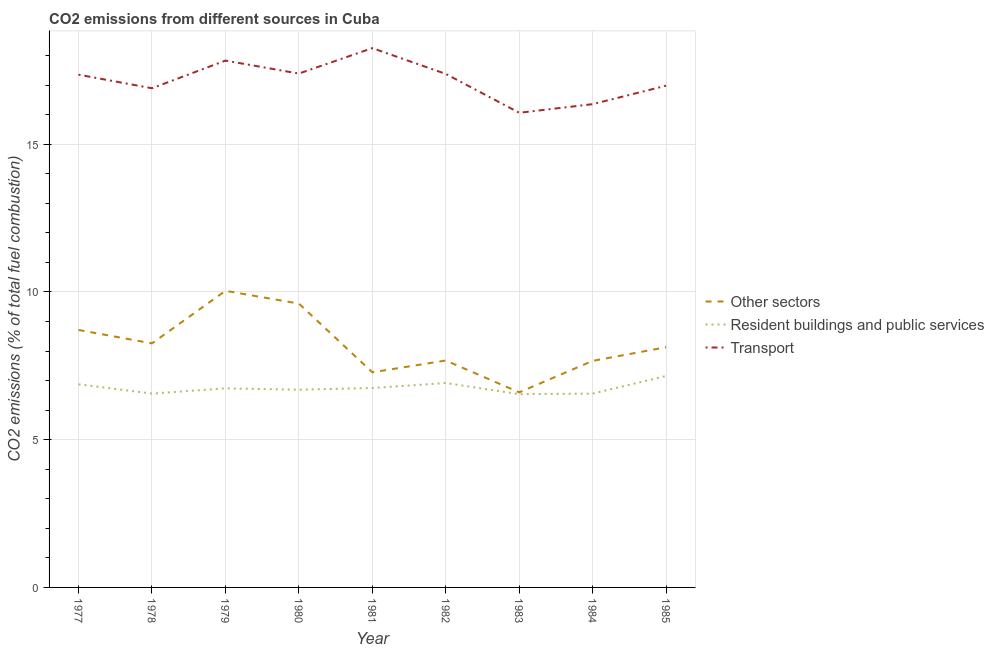How many different coloured lines are there?
Offer a terse response. 3. What is the percentage of co2 emissions from transport in 1982?
Give a very brief answer. 17.38. Across all years, what is the maximum percentage of co2 emissions from transport?
Keep it short and to the point. 18.25. Across all years, what is the minimum percentage of co2 emissions from transport?
Offer a terse response. 16.06. In which year was the percentage of co2 emissions from resident buildings and public services minimum?
Give a very brief answer. 1983. What is the total percentage of co2 emissions from resident buildings and public services in the graph?
Provide a succinct answer. 60.79. What is the difference between the percentage of co2 emissions from transport in 1980 and that in 1981?
Your answer should be compact. -0.86. What is the difference between the percentage of co2 emissions from transport in 1983 and the percentage of co2 emissions from other sectors in 1979?
Provide a short and direct response. 6.03. What is the average percentage of co2 emissions from transport per year?
Keep it short and to the point. 17.17. In the year 1982, what is the difference between the percentage of co2 emissions from transport and percentage of co2 emissions from other sectors?
Provide a succinct answer. 9.7. What is the ratio of the percentage of co2 emissions from resident buildings and public services in 1981 to that in 1985?
Offer a very short reply. 0.94. Is the difference between the percentage of co2 emissions from other sectors in 1977 and 1980 greater than the difference between the percentage of co2 emissions from transport in 1977 and 1980?
Provide a short and direct response. No. What is the difference between the highest and the second highest percentage of co2 emissions from transport?
Your answer should be very brief. 0.42. What is the difference between the highest and the lowest percentage of co2 emissions from other sectors?
Your answer should be very brief. 3.44. Is the sum of the percentage of co2 emissions from resident buildings and public services in 1982 and 1984 greater than the maximum percentage of co2 emissions from other sectors across all years?
Make the answer very short. Yes. Does the percentage of co2 emissions from resident buildings and public services monotonically increase over the years?
Give a very brief answer. No. Is the percentage of co2 emissions from transport strictly greater than the percentage of co2 emissions from other sectors over the years?
Your response must be concise. Yes. Is the percentage of co2 emissions from other sectors strictly less than the percentage of co2 emissions from transport over the years?
Ensure brevity in your answer.  Yes. What is the title of the graph?
Give a very brief answer. CO2 emissions from different sources in Cuba. Does "Argument" appear as one of the legend labels in the graph?
Your answer should be very brief. No. What is the label or title of the Y-axis?
Keep it short and to the point. CO2 emissions (% of total fuel combustion). What is the CO2 emissions (% of total fuel combustion) in Other sectors in 1977?
Give a very brief answer. 8.71. What is the CO2 emissions (% of total fuel combustion) in Resident buildings and public services in 1977?
Give a very brief answer. 6.88. What is the CO2 emissions (% of total fuel combustion) in Transport in 1977?
Your answer should be very brief. 17.35. What is the CO2 emissions (% of total fuel combustion) of Other sectors in 1978?
Make the answer very short. 8.26. What is the CO2 emissions (% of total fuel combustion) of Resident buildings and public services in 1978?
Offer a terse response. 6.56. What is the CO2 emissions (% of total fuel combustion) of Transport in 1978?
Your answer should be compact. 16.89. What is the CO2 emissions (% of total fuel combustion) in Other sectors in 1979?
Your answer should be compact. 10.04. What is the CO2 emissions (% of total fuel combustion) in Resident buildings and public services in 1979?
Provide a succinct answer. 6.74. What is the CO2 emissions (% of total fuel combustion) in Transport in 1979?
Give a very brief answer. 17.83. What is the CO2 emissions (% of total fuel combustion) in Other sectors in 1980?
Your answer should be very brief. 9.61. What is the CO2 emissions (% of total fuel combustion) of Resident buildings and public services in 1980?
Your answer should be compact. 6.69. What is the CO2 emissions (% of total fuel combustion) in Transport in 1980?
Your response must be concise. 17.39. What is the CO2 emissions (% of total fuel combustion) in Other sectors in 1981?
Make the answer very short. 7.28. What is the CO2 emissions (% of total fuel combustion) of Resident buildings and public services in 1981?
Give a very brief answer. 6.75. What is the CO2 emissions (% of total fuel combustion) of Transport in 1981?
Make the answer very short. 18.25. What is the CO2 emissions (% of total fuel combustion) of Other sectors in 1982?
Make the answer very short. 7.68. What is the CO2 emissions (% of total fuel combustion) of Resident buildings and public services in 1982?
Offer a very short reply. 6.92. What is the CO2 emissions (% of total fuel combustion) in Transport in 1982?
Your response must be concise. 17.38. What is the CO2 emissions (% of total fuel combustion) of Other sectors in 1983?
Your response must be concise. 6.6. What is the CO2 emissions (% of total fuel combustion) in Resident buildings and public services in 1983?
Offer a very short reply. 6.54. What is the CO2 emissions (% of total fuel combustion) of Transport in 1983?
Provide a succinct answer. 16.06. What is the CO2 emissions (% of total fuel combustion) in Other sectors in 1984?
Provide a short and direct response. 7.67. What is the CO2 emissions (% of total fuel combustion) in Resident buildings and public services in 1984?
Provide a short and direct response. 6.56. What is the CO2 emissions (% of total fuel combustion) in Transport in 1984?
Provide a short and direct response. 16.36. What is the CO2 emissions (% of total fuel combustion) of Other sectors in 1985?
Ensure brevity in your answer.  8.13. What is the CO2 emissions (% of total fuel combustion) in Resident buildings and public services in 1985?
Give a very brief answer. 7.16. What is the CO2 emissions (% of total fuel combustion) of Transport in 1985?
Offer a terse response. 16.98. Across all years, what is the maximum CO2 emissions (% of total fuel combustion) of Other sectors?
Provide a short and direct response. 10.04. Across all years, what is the maximum CO2 emissions (% of total fuel combustion) in Resident buildings and public services?
Give a very brief answer. 7.16. Across all years, what is the maximum CO2 emissions (% of total fuel combustion) in Transport?
Provide a short and direct response. 18.25. Across all years, what is the minimum CO2 emissions (% of total fuel combustion) in Other sectors?
Offer a terse response. 6.6. Across all years, what is the minimum CO2 emissions (% of total fuel combustion) of Resident buildings and public services?
Offer a very short reply. 6.54. Across all years, what is the minimum CO2 emissions (% of total fuel combustion) in Transport?
Offer a terse response. 16.06. What is the total CO2 emissions (% of total fuel combustion) of Other sectors in the graph?
Provide a short and direct response. 73.98. What is the total CO2 emissions (% of total fuel combustion) in Resident buildings and public services in the graph?
Provide a succinct answer. 60.79. What is the total CO2 emissions (% of total fuel combustion) in Transport in the graph?
Offer a very short reply. 154.49. What is the difference between the CO2 emissions (% of total fuel combustion) of Other sectors in 1977 and that in 1978?
Provide a short and direct response. 0.45. What is the difference between the CO2 emissions (% of total fuel combustion) in Resident buildings and public services in 1977 and that in 1978?
Provide a succinct answer. 0.31. What is the difference between the CO2 emissions (% of total fuel combustion) of Transport in 1977 and that in 1978?
Give a very brief answer. 0.46. What is the difference between the CO2 emissions (% of total fuel combustion) in Other sectors in 1977 and that in 1979?
Ensure brevity in your answer.  -1.32. What is the difference between the CO2 emissions (% of total fuel combustion) in Resident buildings and public services in 1977 and that in 1979?
Offer a terse response. 0.14. What is the difference between the CO2 emissions (% of total fuel combustion) in Transport in 1977 and that in 1979?
Make the answer very short. -0.48. What is the difference between the CO2 emissions (% of total fuel combustion) of Other sectors in 1977 and that in 1980?
Your answer should be very brief. -0.89. What is the difference between the CO2 emissions (% of total fuel combustion) of Resident buildings and public services in 1977 and that in 1980?
Your response must be concise. 0.18. What is the difference between the CO2 emissions (% of total fuel combustion) of Transport in 1977 and that in 1980?
Offer a terse response. -0.04. What is the difference between the CO2 emissions (% of total fuel combustion) of Other sectors in 1977 and that in 1981?
Provide a succinct answer. 1.43. What is the difference between the CO2 emissions (% of total fuel combustion) of Resident buildings and public services in 1977 and that in 1981?
Keep it short and to the point. 0.13. What is the difference between the CO2 emissions (% of total fuel combustion) in Transport in 1977 and that in 1981?
Provide a short and direct response. -0.9. What is the difference between the CO2 emissions (% of total fuel combustion) of Other sectors in 1977 and that in 1982?
Your answer should be very brief. 1.03. What is the difference between the CO2 emissions (% of total fuel combustion) in Resident buildings and public services in 1977 and that in 1982?
Your response must be concise. -0.04. What is the difference between the CO2 emissions (% of total fuel combustion) in Transport in 1977 and that in 1982?
Keep it short and to the point. -0.03. What is the difference between the CO2 emissions (% of total fuel combustion) in Other sectors in 1977 and that in 1983?
Make the answer very short. 2.11. What is the difference between the CO2 emissions (% of total fuel combustion) in Resident buildings and public services in 1977 and that in 1983?
Your answer should be compact. 0.33. What is the difference between the CO2 emissions (% of total fuel combustion) in Transport in 1977 and that in 1983?
Your answer should be compact. 1.29. What is the difference between the CO2 emissions (% of total fuel combustion) of Other sectors in 1977 and that in 1984?
Give a very brief answer. 1.05. What is the difference between the CO2 emissions (% of total fuel combustion) in Resident buildings and public services in 1977 and that in 1984?
Provide a short and direct response. 0.32. What is the difference between the CO2 emissions (% of total fuel combustion) of Transport in 1977 and that in 1984?
Offer a terse response. 1. What is the difference between the CO2 emissions (% of total fuel combustion) in Other sectors in 1977 and that in 1985?
Your answer should be very brief. 0.58. What is the difference between the CO2 emissions (% of total fuel combustion) in Resident buildings and public services in 1977 and that in 1985?
Your answer should be compact. -0.28. What is the difference between the CO2 emissions (% of total fuel combustion) in Transport in 1977 and that in 1985?
Provide a short and direct response. 0.37. What is the difference between the CO2 emissions (% of total fuel combustion) in Other sectors in 1978 and that in 1979?
Your answer should be very brief. -1.78. What is the difference between the CO2 emissions (% of total fuel combustion) in Resident buildings and public services in 1978 and that in 1979?
Make the answer very short. -0.18. What is the difference between the CO2 emissions (% of total fuel combustion) in Transport in 1978 and that in 1979?
Give a very brief answer. -0.94. What is the difference between the CO2 emissions (% of total fuel combustion) in Other sectors in 1978 and that in 1980?
Your answer should be compact. -1.35. What is the difference between the CO2 emissions (% of total fuel combustion) of Resident buildings and public services in 1978 and that in 1980?
Your answer should be very brief. -0.13. What is the difference between the CO2 emissions (% of total fuel combustion) in Transport in 1978 and that in 1980?
Your response must be concise. -0.5. What is the difference between the CO2 emissions (% of total fuel combustion) in Other sectors in 1978 and that in 1981?
Your response must be concise. 0.98. What is the difference between the CO2 emissions (% of total fuel combustion) of Resident buildings and public services in 1978 and that in 1981?
Make the answer very short. -0.19. What is the difference between the CO2 emissions (% of total fuel combustion) in Transport in 1978 and that in 1981?
Provide a short and direct response. -1.36. What is the difference between the CO2 emissions (% of total fuel combustion) of Other sectors in 1978 and that in 1982?
Offer a very short reply. 0.58. What is the difference between the CO2 emissions (% of total fuel combustion) of Resident buildings and public services in 1978 and that in 1982?
Give a very brief answer. -0.36. What is the difference between the CO2 emissions (% of total fuel combustion) in Transport in 1978 and that in 1982?
Your response must be concise. -0.49. What is the difference between the CO2 emissions (% of total fuel combustion) in Other sectors in 1978 and that in 1983?
Offer a terse response. 1.66. What is the difference between the CO2 emissions (% of total fuel combustion) of Resident buildings and public services in 1978 and that in 1983?
Provide a succinct answer. 0.02. What is the difference between the CO2 emissions (% of total fuel combustion) of Transport in 1978 and that in 1983?
Your answer should be very brief. 0.83. What is the difference between the CO2 emissions (% of total fuel combustion) in Other sectors in 1978 and that in 1984?
Your response must be concise. 0.59. What is the difference between the CO2 emissions (% of total fuel combustion) in Transport in 1978 and that in 1984?
Ensure brevity in your answer.  0.54. What is the difference between the CO2 emissions (% of total fuel combustion) of Other sectors in 1978 and that in 1985?
Your response must be concise. 0.13. What is the difference between the CO2 emissions (% of total fuel combustion) of Resident buildings and public services in 1978 and that in 1985?
Your response must be concise. -0.6. What is the difference between the CO2 emissions (% of total fuel combustion) in Transport in 1978 and that in 1985?
Keep it short and to the point. -0.09. What is the difference between the CO2 emissions (% of total fuel combustion) in Other sectors in 1979 and that in 1980?
Your answer should be very brief. 0.43. What is the difference between the CO2 emissions (% of total fuel combustion) of Resident buildings and public services in 1979 and that in 1980?
Provide a succinct answer. 0.05. What is the difference between the CO2 emissions (% of total fuel combustion) of Transport in 1979 and that in 1980?
Keep it short and to the point. 0.44. What is the difference between the CO2 emissions (% of total fuel combustion) in Other sectors in 1979 and that in 1981?
Give a very brief answer. 2.76. What is the difference between the CO2 emissions (% of total fuel combustion) in Resident buildings and public services in 1979 and that in 1981?
Your answer should be very brief. -0.01. What is the difference between the CO2 emissions (% of total fuel combustion) of Transport in 1979 and that in 1981?
Ensure brevity in your answer.  -0.42. What is the difference between the CO2 emissions (% of total fuel combustion) of Other sectors in 1979 and that in 1982?
Your answer should be compact. 2.36. What is the difference between the CO2 emissions (% of total fuel combustion) in Resident buildings and public services in 1979 and that in 1982?
Keep it short and to the point. -0.18. What is the difference between the CO2 emissions (% of total fuel combustion) in Transport in 1979 and that in 1982?
Your answer should be very brief. 0.45. What is the difference between the CO2 emissions (% of total fuel combustion) of Other sectors in 1979 and that in 1983?
Make the answer very short. 3.44. What is the difference between the CO2 emissions (% of total fuel combustion) in Resident buildings and public services in 1979 and that in 1983?
Keep it short and to the point. 0.2. What is the difference between the CO2 emissions (% of total fuel combustion) of Transport in 1979 and that in 1983?
Provide a short and direct response. 1.77. What is the difference between the CO2 emissions (% of total fuel combustion) in Other sectors in 1979 and that in 1984?
Your answer should be compact. 2.37. What is the difference between the CO2 emissions (% of total fuel combustion) in Resident buildings and public services in 1979 and that in 1984?
Your answer should be compact. 0.18. What is the difference between the CO2 emissions (% of total fuel combustion) in Transport in 1979 and that in 1984?
Your response must be concise. 1.47. What is the difference between the CO2 emissions (% of total fuel combustion) in Other sectors in 1979 and that in 1985?
Ensure brevity in your answer.  1.91. What is the difference between the CO2 emissions (% of total fuel combustion) of Resident buildings and public services in 1979 and that in 1985?
Your answer should be very brief. -0.42. What is the difference between the CO2 emissions (% of total fuel combustion) of Transport in 1979 and that in 1985?
Give a very brief answer. 0.85. What is the difference between the CO2 emissions (% of total fuel combustion) in Other sectors in 1980 and that in 1981?
Offer a very short reply. 2.33. What is the difference between the CO2 emissions (% of total fuel combustion) of Resident buildings and public services in 1980 and that in 1981?
Give a very brief answer. -0.06. What is the difference between the CO2 emissions (% of total fuel combustion) in Transport in 1980 and that in 1981?
Your answer should be very brief. -0.86. What is the difference between the CO2 emissions (% of total fuel combustion) in Other sectors in 1980 and that in 1982?
Your answer should be very brief. 1.93. What is the difference between the CO2 emissions (% of total fuel combustion) in Resident buildings and public services in 1980 and that in 1982?
Your response must be concise. -0.23. What is the difference between the CO2 emissions (% of total fuel combustion) in Transport in 1980 and that in 1982?
Your answer should be very brief. 0.01. What is the difference between the CO2 emissions (% of total fuel combustion) in Other sectors in 1980 and that in 1983?
Ensure brevity in your answer.  3. What is the difference between the CO2 emissions (% of total fuel combustion) in Transport in 1980 and that in 1983?
Give a very brief answer. 1.33. What is the difference between the CO2 emissions (% of total fuel combustion) in Other sectors in 1980 and that in 1984?
Offer a terse response. 1.94. What is the difference between the CO2 emissions (% of total fuel combustion) of Resident buildings and public services in 1980 and that in 1984?
Keep it short and to the point. 0.13. What is the difference between the CO2 emissions (% of total fuel combustion) of Transport in 1980 and that in 1984?
Provide a short and direct response. 1.03. What is the difference between the CO2 emissions (% of total fuel combustion) in Other sectors in 1980 and that in 1985?
Your answer should be very brief. 1.48. What is the difference between the CO2 emissions (% of total fuel combustion) in Resident buildings and public services in 1980 and that in 1985?
Ensure brevity in your answer.  -0.47. What is the difference between the CO2 emissions (% of total fuel combustion) of Transport in 1980 and that in 1985?
Keep it short and to the point. 0.41. What is the difference between the CO2 emissions (% of total fuel combustion) in Other sectors in 1981 and that in 1982?
Provide a succinct answer. -0.4. What is the difference between the CO2 emissions (% of total fuel combustion) in Resident buildings and public services in 1981 and that in 1982?
Your response must be concise. -0.17. What is the difference between the CO2 emissions (% of total fuel combustion) in Transport in 1981 and that in 1982?
Provide a short and direct response. 0.87. What is the difference between the CO2 emissions (% of total fuel combustion) in Other sectors in 1981 and that in 1983?
Give a very brief answer. 0.68. What is the difference between the CO2 emissions (% of total fuel combustion) of Resident buildings and public services in 1981 and that in 1983?
Make the answer very short. 0.21. What is the difference between the CO2 emissions (% of total fuel combustion) in Transport in 1981 and that in 1983?
Provide a succinct answer. 2.19. What is the difference between the CO2 emissions (% of total fuel combustion) in Other sectors in 1981 and that in 1984?
Make the answer very short. -0.39. What is the difference between the CO2 emissions (% of total fuel combustion) of Resident buildings and public services in 1981 and that in 1984?
Keep it short and to the point. 0.19. What is the difference between the CO2 emissions (% of total fuel combustion) of Transport in 1981 and that in 1984?
Keep it short and to the point. 1.9. What is the difference between the CO2 emissions (% of total fuel combustion) in Other sectors in 1981 and that in 1985?
Give a very brief answer. -0.85. What is the difference between the CO2 emissions (% of total fuel combustion) in Resident buildings and public services in 1981 and that in 1985?
Your answer should be very brief. -0.41. What is the difference between the CO2 emissions (% of total fuel combustion) in Transport in 1981 and that in 1985?
Keep it short and to the point. 1.27. What is the difference between the CO2 emissions (% of total fuel combustion) of Other sectors in 1982 and that in 1983?
Give a very brief answer. 1.08. What is the difference between the CO2 emissions (% of total fuel combustion) of Resident buildings and public services in 1982 and that in 1983?
Give a very brief answer. 0.38. What is the difference between the CO2 emissions (% of total fuel combustion) in Transport in 1982 and that in 1983?
Offer a terse response. 1.32. What is the difference between the CO2 emissions (% of total fuel combustion) in Other sectors in 1982 and that in 1984?
Your answer should be very brief. 0.01. What is the difference between the CO2 emissions (% of total fuel combustion) in Resident buildings and public services in 1982 and that in 1984?
Provide a succinct answer. 0.36. What is the difference between the CO2 emissions (% of total fuel combustion) of Transport in 1982 and that in 1984?
Make the answer very short. 1.02. What is the difference between the CO2 emissions (% of total fuel combustion) in Other sectors in 1982 and that in 1985?
Give a very brief answer. -0.45. What is the difference between the CO2 emissions (% of total fuel combustion) of Resident buildings and public services in 1982 and that in 1985?
Make the answer very short. -0.24. What is the difference between the CO2 emissions (% of total fuel combustion) in Transport in 1982 and that in 1985?
Provide a succinct answer. 0.4. What is the difference between the CO2 emissions (% of total fuel combustion) in Other sectors in 1983 and that in 1984?
Ensure brevity in your answer.  -1.07. What is the difference between the CO2 emissions (% of total fuel combustion) in Resident buildings and public services in 1983 and that in 1984?
Your answer should be compact. -0.02. What is the difference between the CO2 emissions (% of total fuel combustion) in Transport in 1983 and that in 1984?
Keep it short and to the point. -0.29. What is the difference between the CO2 emissions (% of total fuel combustion) of Other sectors in 1983 and that in 1985?
Make the answer very short. -1.53. What is the difference between the CO2 emissions (% of total fuel combustion) in Resident buildings and public services in 1983 and that in 1985?
Keep it short and to the point. -0.62. What is the difference between the CO2 emissions (% of total fuel combustion) in Transport in 1983 and that in 1985?
Give a very brief answer. -0.92. What is the difference between the CO2 emissions (% of total fuel combustion) in Other sectors in 1984 and that in 1985?
Provide a succinct answer. -0.46. What is the difference between the CO2 emissions (% of total fuel combustion) in Resident buildings and public services in 1984 and that in 1985?
Your answer should be compact. -0.6. What is the difference between the CO2 emissions (% of total fuel combustion) in Transport in 1984 and that in 1985?
Your answer should be very brief. -0.62. What is the difference between the CO2 emissions (% of total fuel combustion) of Other sectors in 1977 and the CO2 emissions (% of total fuel combustion) of Resident buildings and public services in 1978?
Ensure brevity in your answer.  2.15. What is the difference between the CO2 emissions (% of total fuel combustion) of Other sectors in 1977 and the CO2 emissions (% of total fuel combustion) of Transport in 1978?
Your answer should be very brief. -8.18. What is the difference between the CO2 emissions (% of total fuel combustion) in Resident buildings and public services in 1977 and the CO2 emissions (% of total fuel combustion) in Transport in 1978?
Offer a very short reply. -10.02. What is the difference between the CO2 emissions (% of total fuel combustion) of Other sectors in 1977 and the CO2 emissions (% of total fuel combustion) of Resident buildings and public services in 1979?
Your response must be concise. 1.98. What is the difference between the CO2 emissions (% of total fuel combustion) of Other sectors in 1977 and the CO2 emissions (% of total fuel combustion) of Transport in 1979?
Your answer should be compact. -9.12. What is the difference between the CO2 emissions (% of total fuel combustion) in Resident buildings and public services in 1977 and the CO2 emissions (% of total fuel combustion) in Transport in 1979?
Make the answer very short. -10.95. What is the difference between the CO2 emissions (% of total fuel combustion) of Other sectors in 1977 and the CO2 emissions (% of total fuel combustion) of Resident buildings and public services in 1980?
Make the answer very short. 2.02. What is the difference between the CO2 emissions (% of total fuel combustion) of Other sectors in 1977 and the CO2 emissions (% of total fuel combustion) of Transport in 1980?
Your answer should be very brief. -8.68. What is the difference between the CO2 emissions (% of total fuel combustion) of Resident buildings and public services in 1977 and the CO2 emissions (% of total fuel combustion) of Transport in 1980?
Provide a short and direct response. -10.51. What is the difference between the CO2 emissions (% of total fuel combustion) in Other sectors in 1977 and the CO2 emissions (% of total fuel combustion) in Resident buildings and public services in 1981?
Make the answer very short. 1.96. What is the difference between the CO2 emissions (% of total fuel combustion) in Other sectors in 1977 and the CO2 emissions (% of total fuel combustion) in Transport in 1981?
Offer a very short reply. -9.54. What is the difference between the CO2 emissions (% of total fuel combustion) in Resident buildings and public services in 1977 and the CO2 emissions (% of total fuel combustion) in Transport in 1981?
Your response must be concise. -11.38. What is the difference between the CO2 emissions (% of total fuel combustion) of Other sectors in 1977 and the CO2 emissions (% of total fuel combustion) of Resident buildings and public services in 1982?
Offer a terse response. 1.79. What is the difference between the CO2 emissions (% of total fuel combustion) of Other sectors in 1977 and the CO2 emissions (% of total fuel combustion) of Transport in 1982?
Your response must be concise. -8.67. What is the difference between the CO2 emissions (% of total fuel combustion) of Resident buildings and public services in 1977 and the CO2 emissions (% of total fuel combustion) of Transport in 1982?
Offer a terse response. -10.5. What is the difference between the CO2 emissions (% of total fuel combustion) of Other sectors in 1977 and the CO2 emissions (% of total fuel combustion) of Resident buildings and public services in 1983?
Make the answer very short. 2.17. What is the difference between the CO2 emissions (% of total fuel combustion) in Other sectors in 1977 and the CO2 emissions (% of total fuel combustion) in Transport in 1983?
Offer a very short reply. -7.35. What is the difference between the CO2 emissions (% of total fuel combustion) in Resident buildings and public services in 1977 and the CO2 emissions (% of total fuel combustion) in Transport in 1983?
Offer a terse response. -9.19. What is the difference between the CO2 emissions (% of total fuel combustion) of Other sectors in 1977 and the CO2 emissions (% of total fuel combustion) of Resident buildings and public services in 1984?
Offer a terse response. 2.15. What is the difference between the CO2 emissions (% of total fuel combustion) in Other sectors in 1977 and the CO2 emissions (% of total fuel combustion) in Transport in 1984?
Ensure brevity in your answer.  -7.64. What is the difference between the CO2 emissions (% of total fuel combustion) in Resident buildings and public services in 1977 and the CO2 emissions (% of total fuel combustion) in Transport in 1984?
Your response must be concise. -9.48. What is the difference between the CO2 emissions (% of total fuel combustion) in Other sectors in 1977 and the CO2 emissions (% of total fuel combustion) in Resident buildings and public services in 1985?
Your answer should be very brief. 1.56. What is the difference between the CO2 emissions (% of total fuel combustion) in Other sectors in 1977 and the CO2 emissions (% of total fuel combustion) in Transport in 1985?
Provide a succinct answer. -8.27. What is the difference between the CO2 emissions (% of total fuel combustion) of Resident buildings and public services in 1977 and the CO2 emissions (% of total fuel combustion) of Transport in 1985?
Give a very brief answer. -10.11. What is the difference between the CO2 emissions (% of total fuel combustion) in Other sectors in 1978 and the CO2 emissions (% of total fuel combustion) in Resident buildings and public services in 1979?
Offer a very short reply. 1.52. What is the difference between the CO2 emissions (% of total fuel combustion) of Other sectors in 1978 and the CO2 emissions (% of total fuel combustion) of Transport in 1979?
Offer a very short reply. -9.57. What is the difference between the CO2 emissions (% of total fuel combustion) of Resident buildings and public services in 1978 and the CO2 emissions (% of total fuel combustion) of Transport in 1979?
Ensure brevity in your answer.  -11.27. What is the difference between the CO2 emissions (% of total fuel combustion) of Other sectors in 1978 and the CO2 emissions (% of total fuel combustion) of Resident buildings and public services in 1980?
Ensure brevity in your answer.  1.57. What is the difference between the CO2 emissions (% of total fuel combustion) in Other sectors in 1978 and the CO2 emissions (% of total fuel combustion) in Transport in 1980?
Provide a short and direct response. -9.13. What is the difference between the CO2 emissions (% of total fuel combustion) of Resident buildings and public services in 1978 and the CO2 emissions (% of total fuel combustion) of Transport in 1980?
Your answer should be compact. -10.83. What is the difference between the CO2 emissions (% of total fuel combustion) in Other sectors in 1978 and the CO2 emissions (% of total fuel combustion) in Resident buildings and public services in 1981?
Give a very brief answer. 1.51. What is the difference between the CO2 emissions (% of total fuel combustion) of Other sectors in 1978 and the CO2 emissions (% of total fuel combustion) of Transport in 1981?
Your answer should be very brief. -9.99. What is the difference between the CO2 emissions (% of total fuel combustion) of Resident buildings and public services in 1978 and the CO2 emissions (% of total fuel combustion) of Transport in 1981?
Provide a short and direct response. -11.69. What is the difference between the CO2 emissions (% of total fuel combustion) of Other sectors in 1978 and the CO2 emissions (% of total fuel combustion) of Resident buildings and public services in 1982?
Provide a short and direct response. 1.34. What is the difference between the CO2 emissions (% of total fuel combustion) in Other sectors in 1978 and the CO2 emissions (% of total fuel combustion) in Transport in 1982?
Give a very brief answer. -9.12. What is the difference between the CO2 emissions (% of total fuel combustion) of Resident buildings and public services in 1978 and the CO2 emissions (% of total fuel combustion) of Transport in 1982?
Give a very brief answer. -10.82. What is the difference between the CO2 emissions (% of total fuel combustion) in Other sectors in 1978 and the CO2 emissions (% of total fuel combustion) in Resident buildings and public services in 1983?
Your answer should be compact. 1.72. What is the difference between the CO2 emissions (% of total fuel combustion) of Other sectors in 1978 and the CO2 emissions (% of total fuel combustion) of Transport in 1983?
Make the answer very short. -7.8. What is the difference between the CO2 emissions (% of total fuel combustion) of Resident buildings and public services in 1978 and the CO2 emissions (% of total fuel combustion) of Transport in 1983?
Your answer should be compact. -9.5. What is the difference between the CO2 emissions (% of total fuel combustion) in Other sectors in 1978 and the CO2 emissions (% of total fuel combustion) in Resident buildings and public services in 1984?
Provide a succinct answer. 1.7. What is the difference between the CO2 emissions (% of total fuel combustion) in Other sectors in 1978 and the CO2 emissions (% of total fuel combustion) in Transport in 1984?
Offer a very short reply. -8.1. What is the difference between the CO2 emissions (% of total fuel combustion) of Resident buildings and public services in 1978 and the CO2 emissions (% of total fuel combustion) of Transport in 1984?
Offer a very short reply. -9.8. What is the difference between the CO2 emissions (% of total fuel combustion) of Other sectors in 1978 and the CO2 emissions (% of total fuel combustion) of Resident buildings and public services in 1985?
Your response must be concise. 1.1. What is the difference between the CO2 emissions (% of total fuel combustion) in Other sectors in 1978 and the CO2 emissions (% of total fuel combustion) in Transport in 1985?
Ensure brevity in your answer.  -8.72. What is the difference between the CO2 emissions (% of total fuel combustion) in Resident buildings and public services in 1978 and the CO2 emissions (% of total fuel combustion) in Transport in 1985?
Provide a short and direct response. -10.42. What is the difference between the CO2 emissions (% of total fuel combustion) in Other sectors in 1979 and the CO2 emissions (% of total fuel combustion) in Resident buildings and public services in 1980?
Offer a terse response. 3.35. What is the difference between the CO2 emissions (% of total fuel combustion) of Other sectors in 1979 and the CO2 emissions (% of total fuel combustion) of Transport in 1980?
Provide a succinct answer. -7.35. What is the difference between the CO2 emissions (% of total fuel combustion) of Resident buildings and public services in 1979 and the CO2 emissions (% of total fuel combustion) of Transport in 1980?
Your answer should be compact. -10.65. What is the difference between the CO2 emissions (% of total fuel combustion) in Other sectors in 1979 and the CO2 emissions (% of total fuel combustion) in Resident buildings and public services in 1981?
Offer a terse response. 3.29. What is the difference between the CO2 emissions (% of total fuel combustion) in Other sectors in 1979 and the CO2 emissions (% of total fuel combustion) in Transport in 1981?
Provide a succinct answer. -8.21. What is the difference between the CO2 emissions (% of total fuel combustion) of Resident buildings and public services in 1979 and the CO2 emissions (% of total fuel combustion) of Transport in 1981?
Provide a short and direct response. -11.51. What is the difference between the CO2 emissions (% of total fuel combustion) in Other sectors in 1979 and the CO2 emissions (% of total fuel combustion) in Resident buildings and public services in 1982?
Provide a succinct answer. 3.12. What is the difference between the CO2 emissions (% of total fuel combustion) of Other sectors in 1979 and the CO2 emissions (% of total fuel combustion) of Transport in 1982?
Give a very brief answer. -7.34. What is the difference between the CO2 emissions (% of total fuel combustion) of Resident buildings and public services in 1979 and the CO2 emissions (% of total fuel combustion) of Transport in 1982?
Offer a very short reply. -10.64. What is the difference between the CO2 emissions (% of total fuel combustion) of Other sectors in 1979 and the CO2 emissions (% of total fuel combustion) of Resident buildings and public services in 1983?
Ensure brevity in your answer.  3.5. What is the difference between the CO2 emissions (% of total fuel combustion) in Other sectors in 1979 and the CO2 emissions (% of total fuel combustion) in Transport in 1983?
Give a very brief answer. -6.03. What is the difference between the CO2 emissions (% of total fuel combustion) in Resident buildings and public services in 1979 and the CO2 emissions (% of total fuel combustion) in Transport in 1983?
Offer a very short reply. -9.33. What is the difference between the CO2 emissions (% of total fuel combustion) in Other sectors in 1979 and the CO2 emissions (% of total fuel combustion) in Resident buildings and public services in 1984?
Ensure brevity in your answer.  3.48. What is the difference between the CO2 emissions (% of total fuel combustion) of Other sectors in 1979 and the CO2 emissions (% of total fuel combustion) of Transport in 1984?
Offer a very short reply. -6.32. What is the difference between the CO2 emissions (% of total fuel combustion) in Resident buildings and public services in 1979 and the CO2 emissions (% of total fuel combustion) in Transport in 1984?
Provide a succinct answer. -9.62. What is the difference between the CO2 emissions (% of total fuel combustion) of Other sectors in 1979 and the CO2 emissions (% of total fuel combustion) of Resident buildings and public services in 1985?
Keep it short and to the point. 2.88. What is the difference between the CO2 emissions (% of total fuel combustion) in Other sectors in 1979 and the CO2 emissions (% of total fuel combustion) in Transport in 1985?
Ensure brevity in your answer.  -6.94. What is the difference between the CO2 emissions (% of total fuel combustion) of Resident buildings and public services in 1979 and the CO2 emissions (% of total fuel combustion) of Transport in 1985?
Make the answer very short. -10.24. What is the difference between the CO2 emissions (% of total fuel combustion) of Other sectors in 1980 and the CO2 emissions (% of total fuel combustion) of Resident buildings and public services in 1981?
Offer a terse response. 2.86. What is the difference between the CO2 emissions (% of total fuel combustion) in Other sectors in 1980 and the CO2 emissions (% of total fuel combustion) in Transport in 1981?
Provide a short and direct response. -8.65. What is the difference between the CO2 emissions (% of total fuel combustion) of Resident buildings and public services in 1980 and the CO2 emissions (% of total fuel combustion) of Transport in 1981?
Your answer should be very brief. -11.56. What is the difference between the CO2 emissions (% of total fuel combustion) of Other sectors in 1980 and the CO2 emissions (% of total fuel combustion) of Resident buildings and public services in 1982?
Offer a very short reply. 2.69. What is the difference between the CO2 emissions (% of total fuel combustion) of Other sectors in 1980 and the CO2 emissions (% of total fuel combustion) of Transport in 1982?
Your answer should be compact. -7.77. What is the difference between the CO2 emissions (% of total fuel combustion) of Resident buildings and public services in 1980 and the CO2 emissions (% of total fuel combustion) of Transport in 1982?
Your answer should be compact. -10.69. What is the difference between the CO2 emissions (% of total fuel combustion) in Other sectors in 1980 and the CO2 emissions (% of total fuel combustion) in Resident buildings and public services in 1983?
Give a very brief answer. 3.06. What is the difference between the CO2 emissions (% of total fuel combustion) in Other sectors in 1980 and the CO2 emissions (% of total fuel combustion) in Transport in 1983?
Give a very brief answer. -6.46. What is the difference between the CO2 emissions (% of total fuel combustion) of Resident buildings and public services in 1980 and the CO2 emissions (% of total fuel combustion) of Transport in 1983?
Offer a very short reply. -9.37. What is the difference between the CO2 emissions (% of total fuel combustion) of Other sectors in 1980 and the CO2 emissions (% of total fuel combustion) of Resident buildings and public services in 1984?
Provide a short and direct response. 3.05. What is the difference between the CO2 emissions (% of total fuel combustion) in Other sectors in 1980 and the CO2 emissions (% of total fuel combustion) in Transport in 1984?
Provide a short and direct response. -6.75. What is the difference between the CO2 emissions (% of total fuel combustion) of Resident buildings and public services in 1980 and the CO2 emissions (% of total fuel combustion) of Transport in 1984?
Your answer should be very brief. -9.66. What is the difference between the CO2 emissions (% of total fuel combustion) of Other sectors in 1980 and the CO2 emissions (% of total fuel combustion) of Resident buildings and public services in 1985?
Offer a terse response. 2.45. What is the difference between the CO2 emissions (% of total fuel combustion) in Other sectors in 1980 and the CO2 emissions (% of total fuel combustion) in Transport in 1985?
Ensure brevity in your answer.  -7.37. What is the difference between the CO2 emissions (% of total fuel combustion) of Resident buildings and public services in 1980 and the CO2 emissions (% of total fuel combustion) of Transport in 1985?
Give a very brief answer. -10.29. What is the difference between the CO2 emissions (% of total fuel combustion) in Other sectors in 1981 and the CO2 emissions (% of total fuel combustion) in Resident buildings and public services in 1982?
Offer a terse response. 0.36. What is the difference between the CO2 emissions (% of total fuel combustion) in Other sectors in 1981 and the CO2 emissions (% of total fuel combustion) in Transport in 1982?
Your response must be concise. -10.1. What is the difference between the CO2 emissions (% of total fuel combustion) of Resident buildings and public services in 1981 and the CO2 emissions (% of total fuel combustion) of Transport in 1982?
Make the answer very short. -10.63. What is the difference between the CO2 emissions (% of total fuel combustion) in Other sectors in 1981 and the CO2 emissions (% of total fuel combustion) in Resident buildings and public services in 1983?
Provide a succinct answer. 0.74. What is the difference between the CO2 emissions (% of total fuel combustion) in Other sectors in 1981 and the CO2 emissions (% of total fuel combustion) in Transport in 1983?
Your response must be concise. -8.78. What is the difference between the CO2 emissions (% of total fuel combustion) in Resident buildings and public services in 1981 and the CO2 emissions (% of total fuel combustion) in Transport in 1983?
Keep it short and to the point. -9.31. What is the difference between the CO2 emissions (% of total fuel combustion) in Other sectors in 1981 and the CO2 emissions (% of total fuel combustion) in Resident buildings and public services in 1984?
Ensure brevity in your answer.  0.72. What is the difference between the CO2 emissions (% of total fuel combustion) in Other sectors in 1981 and the CO2 emissions (% of total fuel combustion) in Transport in 1984?
Your response must be concise. -9.08. What is the difference between the CO2 emissions (% of total fuel combustion) of Resident buildings and public services in 1981 and the CO2 emissions (% of total fuel combustion) of Transport in 1984?
Your answer should be compact. -9.61. What is the difference between the CO2 emissions (% of total fuel combustion) in Other sectors in 1981 and the CO2 emissions (% of total fuel combustion) in Resident buildings and public services in 1985?
Your answer should be compact. 0.12. What is the difference between the CO2 emissions (% of total fuel combustion) of Other sectors in 1981 and the CO2 emissions (% of total fuel combustion) of Transport in 1985?
Provide a succinct answer. -9.7. What is the difference between the CO2 emissions (% of total fuel combustion) in Resident buildings and public services in 1981 and the CO2 emissions (% of total fuel combustion) in Transport in 1985?
Give a very brief answer. -10.23. What is the difference between the CO2 emissions (% of total fuel combustion) in Other sectors in 1982 and the CO2 emissions (% of total fuel combustion) in Resident buildings and public services in 1983?
Offer a terse response. 1.14. What is the difference between the CO2 emissions (% of total fuel combustion) of Other sectors in 1982 and the CO2 emissions (% of total fuel combustion) of Transport in 1983?
Your answer should be compact. -8.38. What is the difference between the CO2 emissions (% of total fuel combustion) in Resident buildings and public services in 1982 and the CO2 emissions (% of total fuel combustion) in Transport in 1983?
Offer a very short reply. -9.14. What is the difference between the CO2 emissions (% of total fuel combustion) of Other sectors in 1982 and the CO2 emissions (% of total fuel combustion) of Resident buildings and public services in 1984?
Your response must be concise. 1.12. What is the difference between the CO2 emissions (% of total fuel combustion) of Other sectors in 1982 and the CO2 emissions (% of total fuel combustion) of Transport in 1984?
Keep it short and to the point. -8.68. What is the difference between the CO2 emissions (% of total fuel combustion) of Resident buildings and public services in 1982 and the CO2 emissions (% of total fuel combustion) of Transport in 1984?
Ensure brevity in your answer.  -9.44. What is the difference between the CO2 emissions (% of total fuel combustion) in Other sectors in 1982 and the CO2 emissions (% of total fuel combustion) in Resident buildings and public services in 1985?
Offer a very short reply. 0.52. What is the difference between the CO2 emissions (% of total fuel combustion) in Other sectors in 1982 and the CO2 emissions (% of total fuel combustion) in Transport in 1985?
Keep it short and to the point. -9.3. What is the difference between the CO2 emissions (% of total fuel combustion) in Resident buildings and public services in 1982 and the CO2 emissions (% of total fuel combustion) in Transport in 1985?
Your response must be concise. -10.06. What is the difference between the CO2 emissions (% of total fuel combustion) of Other sectors in 1983 and the CO2 emissions (% of total fuel combustion) of Resident buildings and public services in 1984?
Provide a short and direct response. 0.04. What is the difference between the CO2 emissions (% of total fuel combustion) of Other sectors in 1983 and the CO2 emissions (% of total fuel combustion) of Transport in 1984?
Give a very brief answer. -9.75. What is the difference between the CO2 emissions (% of total fuel combustion) in Resident buildings and public services in 1983 and the CO2 emissions (% of total fuel combustion) in Transport in 1984?
Ensure brevity in your answer.  -9.81. What is the difference between the CO2 emissions (% of total fuel combustion) of Other sectors in 1983 and the CO2 emissions (% of total fuel combustion) of Resident buildings and public services in 1985?
Ensure brevity in your answer.  -0.55. What is the difference between the CO2 emissions (% of total fuel combustion) of Other sectors in 1983 and the CO2 emissions (% of total fuel combustion) of Transport in 1985?
Your response must be concise. -10.38. What is the difference between the CO2 emissions (% of total fuel combustion) in Resident buildings and public services in 1983 and the CO2 emissions (% of total fuel combustion) in Transport in 1985?
Offer a terse response. -10.44. What is the difference between the CO2 emissions (% of total fuel combustion) of Other sectors in 1984 and the CO2 emissions (% of total fuel combustion) of Resident buildings and public services in 1985?
Your answer should be compact. 0.51. What is the difference between the CO2 emissions (% of total fuel combustion) in Other sectors in 1984 and the CO2 emissions (% of total fuel combustion) in Transport in 1985?
Offer a terse response. -9.31. What is the difference between the CO2 emissions (% of total fuel combustion) in Resident buildings and public services in 1984 and the CO2 emissions (% of total fuel combustion) in Transport in 1985?
Offer a terse response. -10.42. What is the average CO2 emissions (% of total fuel combustion) in Other sectors per year?
Keep it short and to the point. 8.22. What is the average CO2 emissions (% of total fuel combustion) in Resident buildings and public services per year?
Provide a short and direct response. 6.75. What is the average CO2 emissions (% of total fuel combustion) of Transport per year?
Offer a terse response. 17.17. In the year 1977, what is the difference between the CO2 emissions (% of total fuel combustion) in Other sectors and CO2 emissions (% of total fuel combustion) in Resident buildings and public services?
Keep it short and to the point. 1.84. In the year 1977, what is the difference between the CO2 emissions (% of total fuel combustion) of Other sectors and CO2 emissions (% of total fuel combustion) of Transport?
Make the answer very short. -8.64. In the year 1977, what is the difference between the CO2 emissions (% of total fuel combustion) of Resident buildings and public services and CO2 emissions (% of total fuel combustion) of Transport?
Make the answer very short. -10.48. In the year 1978, what is the difference between the CO2 emissions (% of total fuel combustion) of Other sectors and CO2 emissions (% of total fuel combustion) of Resident buildings and public services?
Your response must be concise. 1.7. In the year 1978, what is the difference between the CO2 emissions (% of total fuel combustion) in Other sectors and CO2 emissions (% of total fuel combustion) in Transport?
Provide a short and direct response. -8.63. In the year 1978, what is the difference between the CO2 emissions (% of total fuel combustion) in Resident buildings and public services and CO2 emissions (% of total fuel combustion) in Transport?
Offer a very short reply. -10.33. In the year 1979, what is the difference between the CO2 emissions (% of total fuel combustion) of Other sectors and CO2 emissions (% of total fuel combustion) of Resident buildings and public services?
Make the answer very short. 3.3. In the year 1979, what is the difference between the CO2 emissions (% of total fuel combustion) in Other sectors and CO2 emissions (% of total fuel combustion) in Transport?
Give a very brief answer. -7.79. In the year 1979, what is the difference between the CO2 emissions (% of total fuel combustion) of Resident buildings and public services and CO2 emissions (% of total fuel combustion) of Transport?
Make the answer very short. -11.09. In the year 1980, what is the difference between the CO2 emissions (% of total fuel combustion) of Other sectors and CO2 emissions (% of total fuel combustion) of Resident buildings and public services?
Offer a terse response. 2.91. In the year 1980, what is the difference between the CO2 emissions (% of total fuel combustion) in Other sectors and CO2 emissions (% of total fuel combustion) in Transport?
Ensure brevity in your answer.  -7.78. In the year 1980, what is the difference between the CO2 emissions (% of total fuel combustion) in Resident buildings and public services and CO2 emissions (% of total fuel combustion) in Transport?
Offer a terse response. -10.7. In the year 1981, what is the difference between the CO2 emissions (% of total fuel combustion) in Other sectors and CO2 emissions (% of total fuel combustion) in Resident buildings and public services?
Your answer should be very brief. 0.53. In the year 1981, what is the difference between the CO2 emissions (% of total fuel combustion) in Other sectors and CO2 emissions (% of total fuel combustion) in Transport?
Give a very brief answer. -10.97. In the year 1981, what is the difference between the CO2 emissions (% of total fuel combustion) in Resident buildings and public services and CO2 emissions (% of total fuel combustion) in Transport?
Offer a very short reply. -11.5. In the year 1982, what is the difference between the CO2 emissions (% of total fuel combustion) in Other sectors and CO2 emissions (% of total fuel combustion) in Resident buildings and public services?
Ensure brevity in your answer.  0.76. In the year 1982, what is the difference between the CO2 emissions (% of total fuel combustion) in Other sectors and CO2 emissions (% of total fuel combustion) in Transport?
Offer a terse response. -9.7. In the year 1982, what is the difference between the CO2 emissions (% of total fuel combustion) in Resident buildings and public services and CO2 emissions (% of total fuel combustion) in Transport?
Offer a very short reply. -10.46. In the year 1983, what is the difference between the CO2 emissions (% of total fuel combustion) in Other sectors and CO2 emissions (% of total fuel combustion) in Resident buildings and public services?
Ensure brevity in your answer.  0.06. In the year 1983, what is the difference between the CO2 emissions (% of total fuel combustion) of Other sectors and CO2 emissions (% of total fuel combustion) of Transport?
Give a very brief answer. -9.46. In the year 1983, what is the difference between the CO2 emissions (% of total fuel combustion) in Resident buildings and public services and CO2 emissions (% of total fuel combustion) in Transport?
Your answer should be very brief. -9.52. In the year 1984, what is the difference between the CO2 emissions (% of total fuel combustion) in Other sectors and CO2 emissions (% of total fuel combustion) in Resident buildings and public services?
Ensure brevity in your answer.  1.11. In the year 1984, what is the difference between the CO2 emissions (% of total fuel combustion) of Other sectors and CO2 emissions (% of total fuel combustion) of Transport?
Provide a succinct answer. -8.69. In the year 1984, what is the difference between the CO2 emissions (% of total fuel combustion) in Resident buildings and public services and CO2 emissions (% of total fuel combustion) in Transport?
Keep it short and to the point. -9.8. In the year 1985, what is the difference between the CO2 emissions (% of total fuel combustion) in Other sectors and CO2 emissions (% of total fuel combustion) in Resident buildings and public services?
Give a very brief answer. 0.97. In the year 1985, what is the difference between the CO2 emissions (% of total fuel combustion) in Other sectors and CO2 emissions (% of total fuel combustion) in Transport?
Offer a very short reply. -8.85. In the year 1985, what is the difference between the CO2 emissions (% of total fuel combustion) of Resident buildings and public services and CO2 emissions (% of total fuel combustion) of Transport?
Offer a very short reply. -9.82. What is the ratio of the CO2 emissions (% of total fuel combustion) of Other sectors in 1977 to that in 1978?
Make the answer very short. 1.05. What is the ratio of the CO2 emissions (% of total fuel combustion) of Resident buildings and public services in 1977 to that in 1978?
Give a very brief answer. 1.05. What is the ratio of the CO2 emissions (% of total fuel combustion) in Transport in 1977 to that in 1978?
Your answer should be compact. 1.03. What is the ratio of the CO2 emissions (% of total fuel combustion) of Other sectors in 1977 to that in 1979?
Your response must be concise. 0.87. What is the ratio of the CO2 emissions (% of total fuel combustion) of Resident buildings and public services in 1977 to that in 1979?
Your answer should be compact. 1.02. What is the ratio of the CO2 emissions (% of total fuel combustion) in Transport in 1977 to that in 1979?
Offer a terse response. 0.97. What is the ratio of the CO2 emissions (% of total fuel combustion) in Other sectors in 1977 to that in 1980?
Make the answer very short. 0.91. What is the ratio of the CO2 emissions (% of total fuel combustion) in Resident buildings and public services in 1977 to that in 1980?
Provide a short and direct response. 1.03. What is the ratio of the CO2 emissions (% of total fuel combustion) in Transport in 1977 to that in 1980?
Your answer should be compact. 1. What is the ratio of the CO2 emissions (% of total fuel combustion) in Other sectors in 1977 to that in 1981?
Your response must be concise. 1.2. What is the ratio of the CO2 emissions (% of total fuel combustion) of Resident buildings and public services in 1977 to that in 1981?
Ensure brevity in your answer.  1.02. What is the ratio of the CO2 emissions (% of total fuel combustion) of Transport in 1977 to that in 1981?
Provide a short and direct response. 0.95. What is the ratio of the CO2 emissions (% of total fuel combustion) in Other sectors in 1977 to that in 1982?
Provide a succinct answer. 1.13. What is the ratio of the CO2 emissions (% of total fuel combustion) in Other sectors in 1977 to that in 1983?
Offer a very short reply. 1.32. What is the ratio of the CO2 emissions (% of total fuel combustion) in Resident buildings and public services in 1977 to that in 1983?
Make the answer very short. 1.05. What is the ratio of the CO2 emissions (% of total fuel combustion) in Transport in 1977 to that in 1983?
Give a very brief answer. 1.08. What is the ratio of the CO2 emissions (% of total fuel combustion) in Other sectors in 1977 to that in 1984?
Provide a short and direct response. 1.14. What is the ratio of the CO2 emissions (% of total fuel combustion) in Resident buildings and public services in 1977 to that in 1984?
Keep it short and to the point. 1.05. What is the ratio of the CO2 emissions (% of total fuel combustion) of Transport in 1977 to that in 1984?
Keep it short and to the point. 1.06. What is the ratio of the CO2 emissions (% of total fuel combustion) of Other sectors in 1977 to that in 1985?
Give a very brief answer. 1.07. What is the ratio of the CO2 emissions (% of total fuel combustion) in Resident buildings and public services in 1977 to that in 1985?
Offer a terse response. 0.96. What is the ratio of the CO2 emissions (% of total fuel combustion) of Transport in 1977 to that in 1985?
Your answer should be compact. 1.02. What is the ratio of the CO2 emissions (% of total fuel combustion) of Other sectors in 1978 to that in 1979?
Provide a short and direct response. 0.82. What is the ratio of the CO2 emissions (% of total fuel combustion) in Resident buildings and public services in 1978 to that in 1979?
Provide a short and direct response. 0.97. What is the ratio of the CO2 emissions (% of total fuel combustion) of Transport in 1978 to that in 1979?
Make the answer very short. 0.95. What is the ratio of the CO2 emissions (% of total fuel combustion) of Other sectors in 1978 to that in 1980?
Ensure brevity in your answer.  0.86. What is the ratio of the CO2 emissions (% of total fuel combustion) of Resident buildings and public services in 1978 to that in 1980?
Provide a short and direct response. 0.98. What is the ratio of the CO2 emissions (% of total fuel combustion) of Transport in 1978 to that in 1980?
Your answer should be compact. 0.97. What is the ratio of the CO2 emissions (% of total fuel combustion) of Other sectors in 1978 to that in 1981?
Keep it short and to the point. 1.13. What is the ratio of the CO2 emissions (% of total fuel combustion) in Resident buildings and public services in 1978 to that in 1981?
Offer a very short reply. 0.97. What is the ratio of the CO2 emissions (% of total fuel combustion) in Transport in 1978 to that in 1981?
Offer a very short reply. 0.93. What is the ratio of the CO2 emissions (% of total fuel combustion) in Other sectors in 1978 to that in 1982?
Provide a short and direct response. 1.08. What is the ratio of the CO2 emissions (% of total fuel combustion) in Resident buildings and public services in 1978 to that in 1982?
Your answer should be compact. 0.95. What is the ratio of the CO2 emissions (% of total fuel combustion) in Transport in 1978 to that in 1982?
Your response must be concise. 0.97. What is the ratio of the CO2 emissions (% of total fuel combustion) of Other sectors in 1978 to that in 1983?
Give a very brief answer. 1.25. What is the ratio of the CO2 emissions (% of total fuel combustion) in Transport in 1978 to that in 1983?
Your response must be concise. 1.05. What is the ratio of the CO2 emissions (% of total fuel combustion) of Other sectors in 1978 to that in 1984?
Offer a terse response. 1.08. What is the ratio of the CO2 emissions (% of total fuel combustion) of Transport in 1978 to that in 1984?
Your answer should be compact. 1.03. What is the ratio of the CO2 emissions (% of total fuel combustion) in Other sectors in 1978 to that in 1985?
Provide a succinct answer. 1.02. What is the ratio of the CO2 emissions (% of total fuel combustion) of Resident buildings and public services in 1978 to that in 1985?
Offer a very short reply. 0.92. What is the ratio of the CO2 emissions (% of total fuel combustion) in Transport in 1978 to that in 1985?
Give a very brief answer. 0.99. What is the ratio of the CO2 emissions (% of total fuel combustion) of Other sectors in 1979 to that in 1980?
Give a very brief answer. 1.04. What is the ratio of the CO2 emissions (% of total fuel combustion) in Resident buildings and public services in 1979 to that in 1980?
Your answer should be compact. 1.01. What is the ratio of the CO2 emissions (% of total fuel combustion) of Transport in 1979 to that in 1980?
Offer a terse response. 1.03. What is the ratio of the CO2 emissions (% of total fuel combustion) in Other sectors in 1979 to that in 1981?
Your answer should be very brief. 1.38. What is the ratio of the CO2 emissions (% of total fuel combustion) in Transport in 1979 to that in 1981?
Your answer should be compact. 0.98. What is the ratio of the CO2 emissions (% of total fuel combustion) of Other sectors in 1979 to that in 1982?
Make the answer very short. 1.31. What is the ratio of the CO2 emissions (% of total fuel combustion) of Resident buildings and public services in 1979 to that in 1982?
Your response must be concise. 0.97. What is the ratio of the CO2 emissions (% of total fuel combustion) in Transport in 1979 to that in 1982?
Offer a terse response. 1.03. What is the ratio of the CO2 emissions (% of total fuel combustion) of Other sectors in 1979 to that in 1983?
Offer a very short reply. 1.52. What is the ratio of the CO2 emissions (% of total fuel combustion) of Resident buildings and public services in 1979 to that in 1983?
Your answer should be compact. 1.03. What is the ratio of the CO2 emissions (% of total fuel combustion) of Transport in 1979 to that in 1983?
Give a very brief answer. 1.11. What is the ratio of the CO2 emissions (% of total fuel combustion) of Other sectors in 1979 to that in 1984?
Offer a terse response. 1.31. What is the ratio of the CO2 emissions (% of total fuel combustion) in Transport in 1979 to that in 1984?
Make the answer very short. 1.09. What is the ratio of the CO2 emissions (% of total fuel combustion) in Other sectors in 1979 to that in 1985?
Provide a short and direct response. 1.23. What is the ratio of the CO2 emissions (% of total fuel combustion) in Resident buildings and public services in 1979 to that in 1985?
Your answer should be very brief. 0.94. What is the ratio of the CO2 emissions (% of total fuel combustion) of Transport in 1979 to that in 1985?
Keep it short and to the point. 1.05. What is the ratio of the CO2 emissions (% of total fuel combustion) of Other sectors in 1980 to that in 1981?
Your answer should be compact. 1.32. What is the ratio of the CO2 emissions (% of total fuel combustion) of Resident buildings and public services in 1980 to that in 1981?
Make the answer very short. 0.99. What is the ratio of the CO2 emissions (% of total fuel combustion) in Transport in 1980 to that in 1981?
Your answer should be very brief. 0.95. What is the ratio of the CO2 emissions (% of total fuel combustion) of Other sectors in 1980 to that in 1982?
Offer a very short reply. 1.25. What is the ratio of the CO2 emissions (% of total fuel combustion) in Resident buildings and public services in 1980 to that in 1982?
Your answer should be very brief. 0.97. What is the ratio of the CO2 emissions (% of total fuel combustion) in Other sectors in 1980 to that in 1983?
Keep it short and to the point. 1.46. What is the ratio of the CO2 emissions (% of total fuel combustion) of Resident buildings and public services in 1980 to that in 1983?
Keep it short and to the point. 1.02. What is the ratio of the CO2 emissions (% of total fuel combustion) of Transport in 1980 to that in 1983?
Provide a short and direct response. 1.08. What is the ratio of the CO2 emissions (% of total fuel combustion) of Other sectors in 1980 to that in 1984?
Keep it short and to the point. 1.25. What is the ratio of the CO2 emissions (% of total fuel combustion) of Resident buildings and public services in 1980 to that in 1984?
Provide a short and direct response. 1.02. What is the ratio of the CO2 emissions (% of total fuel combustion) in Transport in 1980 to that in 1984?
Provide a succinct answer. 1.06. What is the ratio of the CO2 emissions (% of total fuel combustion) in Other sectors in 1980 to that in 1985?
Your answer should be compact. 1.18. What is the ratio of the CO2 emissions (% of total fuel combustion) of Resident buildings and public services in 1980 to that in 1985?
Make the answer very short. 0.94. What is the ratio of the CO2 emissions (% of total fuel combustion) in Transport in 1980 to that in 1985?
Ensure brevity in your answer.  1.02. What is the ratio of the CO2 emissions (% of total fuel combustion) in Other sectors in 1981 to that in 1982?
Offer a very short reply. 0.95. What is the ratio of the CO2 emissions (% of total fuel combustion) in Resident buildings and public services in 1981 to that in 1982?
Give a very brief answer. 0.98. What is the ratio of the CO2 emissions (% of total fuel combustion) of Transport in 1981 to that in 1982?
Your answer should be compact. 1.05. What is the ratio of the CO2 emissions (% of total fuel combustion) of Other sectors in 1981 to that in 1983?
Make the answer very short. 1.1. What is the ratio of the CO2 emissions (% of total fuel combustion) in Resident buildings and public services in 1981 to that in 1983?
Ensure brevity in your answer.  1.03. What is the ratio of the CO2 emissions (% of total fuel combustion) in Transport in 1981 to that in 1983?
Your response must be concise. 1.14. What is the ratio of the CO2 emissions (% of total fuel combustion) of Other sectors in 1981 to that in 1984?
Offer a terse response. 0.95. What is the ratio of the CO2 emissions (% of total fuel combustion) of Resident buildings and public services in 1981 to that in 1984?
Keep it short and to the point. 1.03. What is the ratio of the CO2 emissions (% of total fuel combustion) in Transport in 1981 to that in 1984?
Your response must be concise. 1.12. What is the ratio of the CO2 emissions (% of total fuel combustion) of Other sectors in 1981 to that in 1985?
Provide a succinct answer. 0.9. What is the ratio of the CO2 emissions (% of total fuel combustion) in Resident buildings and public services in 1981 to that in 1985?
Keep it short and to the point. 0.94. What is the ratio of the CO2 emissions (% of total fuel combustion) in Transport in 1981 to that in 1985?
Provide a succinct answer. 1.07. What is the ratio of the CO2 emissions (% of total fuel combustion) in Other sectors in 1982 to that in 1983?
Provide a succinct answer. 1.16. What is the ratio of the CO2 emissions (% of total fuel combustion) of Resident buildings and public services in 1982 to that in 1983?
Provide a short and direct response. 1.06. What is the ratio of the CO2 emissions (% of total fuel combustion) of Transport in 1982 to that in 1983?
Keep it short and to the point. 1.08. What is the ratio of the CO2 emissions (% of total fuel combustion) in Other sectors in 1982 to that in 1984?
Offer a very short reply. 1. What is the ratio of the CO2 emissions (% of total fuel combustion) of Resident buildings and public services in 1982 to that in 1984?
Your response must be concise. 1.05. What is the ratio of the CO2 emissions (% of total fuel combustion) of Transport in 1982 to that in 1984?
Provide a short and direct response. 1.06. What is the ratio of the CO2 emissions (% of total fuel combustion) in Other sectors in 1982 to that in 1985?
Your response must be concise. 0.94. What is the ratio of the CO2 emissions (% of total fuel combustion) in Resident buildings and public services in 1982 to that in 1985?
Offer a terse response. 0.97. What is the ratio of the CO2 emissions (% of total fuel combustion) of Transport in 1982 to that in 1985?
Provide a short and direct response. 1.02. What is the ratio of the CO2 emissions (% of total fuel combustion) of Other sectors in 1983 to that in 1984?
Ensure brevity in your answer.  0.86. What is the ratio of the CO2 emissions (% of total fuel combustion) in Transport in 1983 to that in 1984?
Ensure brevity in your answer.  0.98. What is the ratio of the CO2 emissions (% of total fuel combustion) in Other sectors in 1983 to that in 1985?
Offer a very short reply. 0.81. What is the ratio of the CO2 emissions (% of total fuel combustion) in Resident buildings and public services in 1983 to that in 1985?
Your response must be concise. 0.91. What is the ratio of the CO2 emissions (% of total fuel combustion) of Transport in 1983 to that in 1985?
Ensure brevity in your answer.  0.95. What is the ratio of the CO2 emissions (% of total fuel combustion) of Other sectors in 1984 to that in 1985?
Provide a succinct answer. 0.94. What is the ratio of the CO2 emissions (% of total fuel combustion) of Resident buildings and public services in 1984 to that in 1985?
Your answer should be very brief. 0.92. What is the ratio of the CO2 emissions (% of total fuel combustion) of Transport in 1984 to that in 1985?
Offer a very short reply. 0.96. What is the difference between the highest and the second highest CO2 emissions (% of total fuel combustion) of Other sectors?
Provide a succinct answer. 0.43. What is the difference between the highest and the second highest CO2 emissions (% of total fuel combustion) in Resident buildings and public services?
Ensure brevity in your answer.  0.24. What is the difference between the highest and the second highest CO2 emissions (% of total fuel combustion) in Transport?
Provide a succinct answer. 0.42. What is the difference between the highest and the lowest CO2 emissions (% of total fuel combustion) in Other sectors?
Keep it short and to the point. 3.44. What is the difference between the highest and the lowest CO2 emissions (% of total fuel combustion) of Resident buildings and public services?
Keep it short and to the point. 0.62. What is the difference between the highest and the lowest CO2 emissions (% of total fuel combustion) in Transport?
Provide a short and direct response. 2.19. 